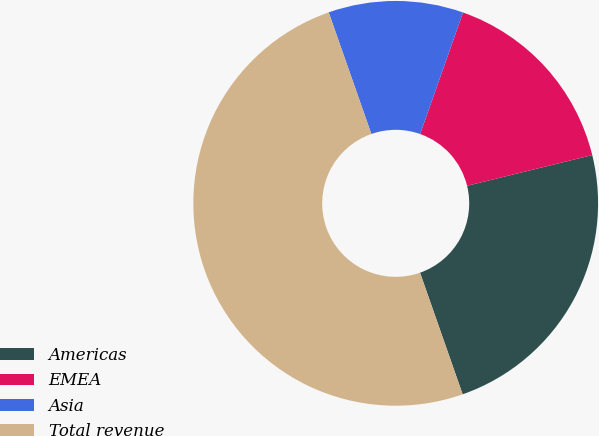Convert chart to OTSL. <chart><loc_0><loc_0><loc_500><loc_500><pie_chart><fcel>Americas<fcel>EMEA<fcel>Asia<fcel>Total revenue<nl><fcel>23.47%<fcel>15.77%<fcel>10.77%<fcel>50.0%<nl></chart> 